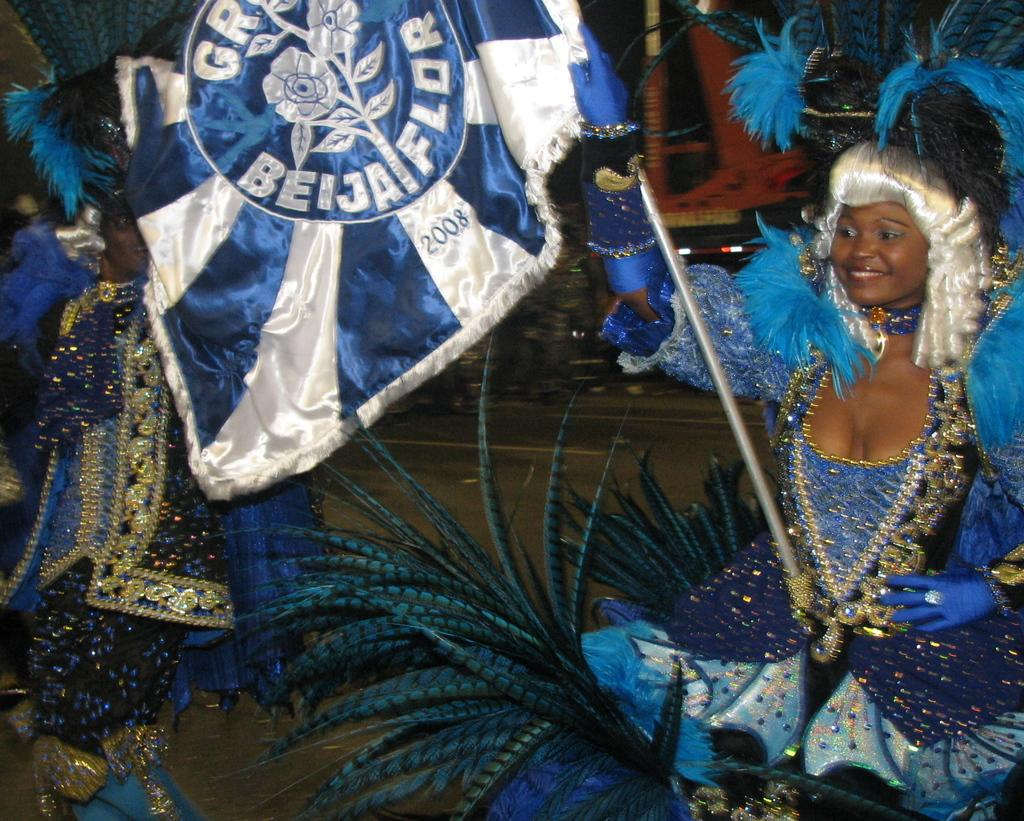Who is on the right side of the image? There is a lady on the right side of the image. What is the lady on the right side of the image holding? The lady on the right side of the image is holding a flag in her hand. What is the lady on the right side of the image wearing? The lady on the right side of the image is wearing a costume. Who is on the left side of the image? There is another lady on the left side of the image. What statement does the lady's aunt make about her costume in the image? There is no mention of an aunt in the image, so it is not possible to answer that question. 